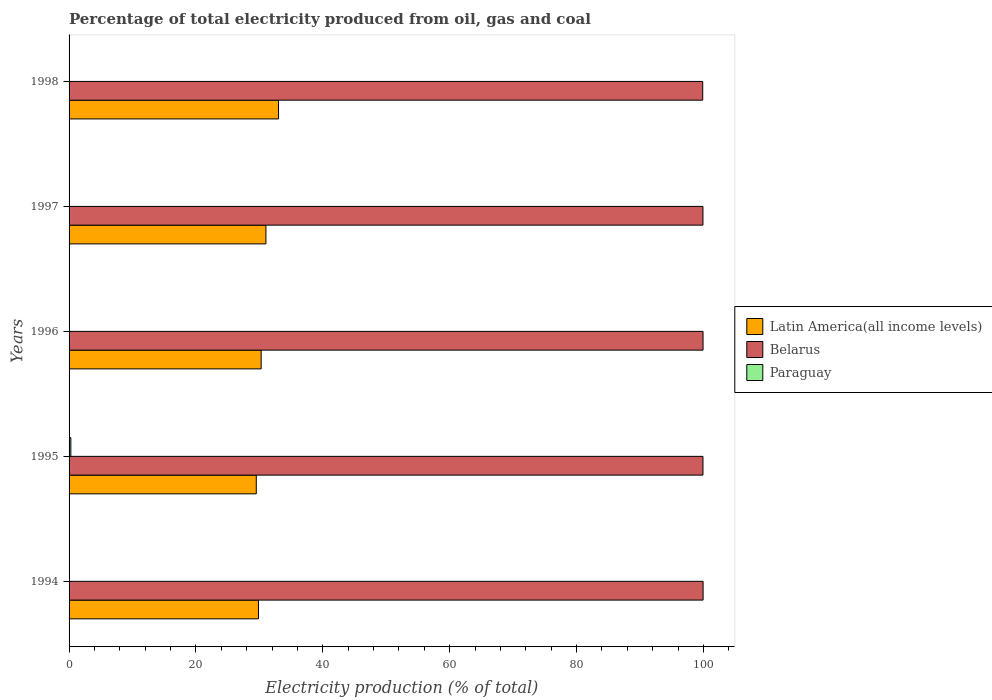How many different coloured bars are there?
Keep it short and to the point. 3. How many groups of bars are there?
Make the answer very short. 5. Are the number of bars per tick equal to the number of legend labels?
Make the answer very short. Yes. How many bars are there on the 1st tick from the top?
Provide a succinct answer. 3. How many bars are there on the 4th tick from the bottom?
Ensure brevity in your answer.  3. In how many cases, is the number of bars for a given year not equal to the number of legend labels?
Your answer should be very brief. 0. What is the electricity production in in Belarus in 1996?
Your answer should be very brief. 99.93. Across all years, what is the maximum electricity production in in Belarus?
Provide a succinct answer. 99.94. Across all years, what is the minimum electricity production in in Belarus?
Offer a very short reply. 99.88. In which year was the electricity production in in Paraguay minimum?
Your answer should be very brief. 1994. What is the total electricity production in in Latin America(all income levels) in the graph?
Your response must be concise. 153.7. What is the difference between the electricity production in in Latin America(all income levels) in 1996 and that in 1997?
Your answer should be compact. -0.75. What is the difference between the electricity production in in Latin America(all income levels) in 1994 and the electricity production in in Belarus in 1998?
Make the answer very short. -70.02. What is the average electricity production in in Paraguay per year?
Give a very brief answer. 0.08. In the year 1997, what is the difference between the electricity production in in Latin America(all income levels) and electricity production in in Belarus?
Give a very brief answer. -68.89. What is the ratio of the electricity production in in Paraguay in 1995 to that in 1998?
Offer a very short reply. 13.03. What is the difference between the highest and the second highest electricity production in in Paraguay?
Your response must be concise. 0.25. What is the difference between the highest and the lowest electricity production in in Latin America(all income levels)?
Your answer should be very brief. 3.51. In how many years, is the electricity production in in Belarus greater than the average electricity production in in Belarus taken over all years?
Make the answer very short. 4. Is the sum of the electricity production in in Latin America(all income levels) in 1996 and 1997 greater than the maximum electricity production in in Paraguay across all years?
Offer a terse response. Yes. What does the 3rd bar from the top in 1996 represents?
Provide a succinct answer. Latin America(all income levels). What does the 1st bar from the bottom in 1996 represents?
Provide a short and direct response. Latin America(all income levels). How many bars are there?
Your response must be concise. 15. Are all the bars in the graph horizontal?
Your response must be concise. Yes. What is the difference between two consecutive major ticks on the X-axis?
Offer a very short reply. 20. How many legend labels are there?
Make the answer very short. 3. What is the title of the graph?
Your answer should be compact. Percentage of total electricity produced from oil, gas and coal. What is the label or title of the X-axis?
Provide a succinct answer. Electricity production (% of total). What is the Electricity production (% of total) in Latin America(all income levels) in 1994?
Keep it short and to the point. 29.86. What is the Electricity production (% of total) of Belarus in 1994?
Your response must be concise. 99.94. What is the Electricity production (% of total) in Paraguay in 1994?
Ensure brevity in your answer.  0.02. What is the Electricity production (% of total) of Latin America(all income levels) in 1995?
Keep it short and to the point. 29.51. What is the Electricity production (% of total) in Belarus in 1995?
Offer a very short reply. 99.92. What is the Electricity production (% of total) of Paraguay in 1995?
Your answer should be very brief. 0.28. What is the Electricity production (% of total) of Latin America(all income levels) in 1996?
Provide a short and direct response. 30.28. What is the Electricity production (% of total) in Belarus in 1996?
Make the answer very short. 99.93. What is the Electricity production (% of total) in Paraguay in 1996?
Provide a short and direct response. 0.03. What is the Electricity production (% of total) in Latin America(all income levels) in 1997?
Your response must be concise. 31.03. What is the Electricity production (% of total) in Belarus in 1997?
Your answer should be compact. 99.92. What is the Electricity production (% of total) in Paraguay in 1997?
Keep it short and to the point. 0.02. What is the Electricity production (% of total) in Latin America(all income levels) in 1998?
Your answer should be compact. 33.02. What is the Electricity production (% of total) in Belarus in 1998?
Ensure brevity in your answer.  99.88. What is the Electricity production (% of total) of Paraguay in 1998?
Offer a very short reply. 0.02. Across all years, what is the maximum Electricity production (% of total) of Latin America(all income levels)?
Give a very brief answer. 33.02. Across all years, what is the maximum Electricity production (% of total) of Belarus?
Make the answer very short. 99.94. Across all years, what is the maximum Electricity production (% of total) in Paraguay?
Your answer should be very brief. 0.28. Across all years, what is the minimum Electricity production (% of total) in Latin America(all income levels)?
Make the answer very short. 29.51. Across all years, what is the minimum Electricity production (% of total) in Belarus?
Make the answer very short. 99.88. Across all years, what is the minimum Electricity production (% of total) in Paraguay?
Provide a short and direct response. 0.02. What is the total Electricity production (% of total) of Latin America(all income levels) in the graph?
Your response must be concise. 153.7. What is the total Electricity production (% of total) in Belarus in the graph?
Your answer should be very brief. 499.59. What is the total Electricity production (% of total) of Paraguay in the graph?
Give a very brief answer. 0.38. What is the difference between the Electricity production (% of total) of Latin America(all income levels) in 1994 and that in 1995?
Ensure brevity in your answer.  0.35. What is the difference between the Electricity production (% of total) of Belarus in 1994 and that in 1995?
Your answer should be compact. 0.02. What is the difference between the Electricity production (% of total) in Paraguay in 1994 and that in 1995?
Make the answer very short. -0.26. What is the difference between the Electricity production (% of total) of Latin America(all income levels) in 1994 and that in 1996?
Your response must be concise. -0.42. What is the difference between the Electricity production (% of total) in Belarus in 1994 and that in 1996?
Your answer should be very brief. 0.01. What is the difference between the Electricity production (% of total) in Paraguay in 1994 and that in 1996?
Provide a succinct answer. -0.01. What is the difference between the Electricity production (% of total) of Latin America(all income levels) in 1994 and that in 1997?
Keep it short and to the point. -1.18. What is the difference between the Electricity production (% of total) in Belarus in 1994 and that in 1997?
Your answer should be very brief. 0.02. What is the difference between the Electricity production (% of total) in Paraguay in 1994 and that in 1997?
Offer a very short reply. -0. What is the difference between the Electricity production (% of total) of Latin America(all income levels) in 1994 and that in 1998?
Provide a short and direct response. -3.16. What is the difference between the Electricity production (% of total) of Belarus in 1994 and that in 1998?
Keep it short and to the point. 0.06. What is the difference between the Electricity production (% of total) of Paraguay in 1994 and that in 1998?
Your response must be concise. -0. What is the difference between the Electricity production (% of total) of Latin America(all income levels) in 1995 and that in 1996?
Give a very brief answer. -0.77. What is the difference between the Electricity production (% of total) of Belarus in 1995 and that in 1996?
Ensure brevity in your answer.  -0.01. What is the difference between the Electricity production (% of total) of Paraguay in 1995 and that in 1996?
Ensure brevity in your answer.  0.25. What is the difference between the Electricity production (% of total) of Latin America(all income levels) in 1995 and that in 1997?
Give a very brief answer. -1.52. What is the difference between the Electricity production (% of total) in Belarus in 1995 and that in 1997?
Your answer should be very brief. 0. What is the difference between the Electricity production (% of total) in Paraguay in 1995 and that in 1997?
Your answer should be compact. 0.26. What is the difference between the Electricity production (% of total) in Latin America(all income levels) in 1995 and that in 1998?
Provide a short and direct response. -3.51. What is the difference between the Electricity production (% of total) in Belarus in 1995 and that in 1998?
Your answer should be very brief. 0.04. What is the difference between the Electricity production (% of total) in Paraguay in 1995 and that in 1998?
Offer a terse response. 0.26. What is the difference between the Electricity production (% of total) of Latin America(all income levels) in 1996 and that in 1997?
Your answer should be compact. -0.75. What is the difference between the Electricity production (% of total) in Belarus in 1996 and that in 1997?
Provide a short and direct response. 0.01. What is the difference between the Electricity production (% of total) in Paraguay in 1996 and that in 1997?
Make the answer very short. 0.01. What is the difference between the Electricity production (% of total) in Latin America(all income levels) in 1996 and that in 1998?
Make the answer very short. -2.74. What is the difference between the Electricity production (% of total) of Belarus in 1996 and that in 1998?
Offer a terse response. 0.05. What is the difference between the Electricity production (% of total) of Paraguay in 1996 and that in 1998?
Give a very brief answer. 0.01. What is the difference between the Electricity production (% of total) of Latin America(all income levels) in 1997 and that in 1998?
Offer a terse response. -1.98. What is the difference between the Electricity production (% of total) of Belarus in 1997 and that in 1998?
Your answer should be very brief. 0.04. What is the difference between the Electricity production (% of total) of Paraguay in 1997 and that in 1998?
Your answer should be compact. 0. What is the difference between the Electricity production (% of total) in Latin America(all income levels) in 1994 and the Electricity production (% of total) in Belarus in 1995?
Provide a succinct answer. -70.06. What is the difference between the Electricity production (% of total) in Latin America(all income levels) in 1994 and the Electricity production (% of total) in Paraguay in 1995?
Offer a very short reply. 29.58. What is the difference between the Electricity production (% of total) in Belarus in 1994 and the Electricity production (% of total) in Paraguay in 1995?
Offer a very short reply. 99.66. What is the difference between the Electricity production (% of total) in Latin America(all income levels) in 1994 and the Electricity production (% of total) in Belarus in 1996?
Ensure brevity in your answer.  -70.08. What is the difference between the Electricity production (% of total) of Latin America(all income levels) in 1994 and the Electricity production (% of total) of Paraguay in 1996?
Make the answer very short. 29.82. What is the difference between the Electricity production (% of total) in Belarus in 1994 and the Electricity production (% of total) in Paraguay in 1996?
Your answer should be very brief. 99.91. What is the difference between the Electricity production (% of total) of Latin America(all income levels) in 1994 and the Electricity production (% of total) of Belarus in 1997?
Offer a terse response. -70.06. What is the difference between the Electricity production (% of total) in Latin America(all income levels) in 1994 and the Electricity production (% of total) in Paraguay in 1997?
Provide a succinct answer. 29.84. What is the difference between the Electricity production (% of total) of Belarus in 1994 and the Electricity production (% of total) of Paraguay in 1997?
Your response must be concise. 99.92. What is the difference between the Electricity production (% of total) in Latin America(all income levels) in 1994 and the Electricity production (% of total) in Belarus in 1998?
Ensure brevity in your answer.  -70.02. What is the difference between the Electricity production (% of total) in Latin America(all income levels) in 1994 and the Electricity production (% of total) in Paraguay in 1998?
Provide a succinct answer. 29.84. What is the difference between the Electricity production (% of total) of Belarus in 1994 and the Electricity production (% of total) of Paraguay in 1998?
Make the answer very short. 99.92. What is the difference between the Electricity production (% of total) in Latin America(all income levels) in 1995 and the Electricity production (% of total) in Belarus in 1996?
Offer a terse response. -70.42. What is the difference between the Electricity production (% of total) in Latin America(all income levels) in 1995 and the Electricity production (% of total) in Paraguay in 1996?
Provide a short and direct response. 29.48. What is the difference between the Electricity production (% of total) in Belarus in 1995 and the Electricity production (% of total) in Paraguay in 1996?
Give a very brief answer. 99.89. What is the difference between the Electricity production (% of total) in Latin America(all income levels) in 1995 and the Electricity production (% of total) in Belarus in 1997?
Ensure brevity in your answer.  -70.41. What is the difference between the Electricity production (% of total) in Latin America(all income levels) in 1995 and the Electricity production (% of total) in Paraguay in 1997?
Offer a very short reply. 29.49. What is the difference between the Electricity production (% of total) of Belarus in 1995 and the Electricity production (% of total) of Paraguay in 1997?
Make the answer very short. 99.9. What is the difference between the Electricity production (% of total) of Latin America(all income levels) in 1995 and the Electricity production (% of total) of Belarus in 1998?
Your response must be concise. -70.37. What is the difference between the Electricity production (% of total) of Latin America(all income levels) in 1995 and the Electricity production (% of total) of Paraguay in 1998?
Your answer should be compact. 29.49. What is the difference between the Electricity production (% of total) in Belarus in 1995 and the Electricity production (% of total) in Paraguay in 1998?
Your answer should be compact. 99.9. What is the difference between the Electricity production (% of total) in Latin America(all income levels) in 1996 and the Electricity production (% of total) in Belarus in 1997?
Keep it short and to the point. -69.64. What is the difference between the Electricity production (% of total) of Latin America(all income levels) in 1996 and the Electricity production (% of total) of Paraguay in 1997?
Provide a succinct answer. 30.26. What is the difference between the Electricity production (% of total) in Belarus in 1996 and the Electricity production (% of total) in Paraguay in 1997?
Your response must be concise. 99.91. What is the difference between the Electricity production (% of total) in Latin America(all income levels) in 1996 and the Electricity production (% of total) in Belarus in 1998?
Make the answer very short. -69.6. What is the difference between the Electricity production (% of total) in Latin America(all income levels) in 1996 and the Electricity production (% of total) in Paraguay in 1998?
Your answer should be compact. 30.26. What is the difference between the Electricity production (% of total) in Belarus in 1996 and the Electricity production (% of total) in Paraguay in 1998?
Provide a succinct answer. 99.91. What is the difference between the Electricity production (% of total) of Latin America(all income levels) in 1997 and the Electricity production (% of total) of Belarus in 1998?
Give a very brief answer. -68.85. What is the difference between the Electricity production (% of total) of Latin America(all income levels) in 1997 and the Electricity production (% of total) of Paraguay in 1998?
Provide a succinct answer. 31.01. What is the difference between the Electricity production (% of total) in Belarus in 1997 and the Electricity production (% of total) in Paraguay in 1998?
Make the answer very short. 99.9. What is the average Electricity production (% of total) in Latin America(all income levels) per year?
Provide a short and direct response. 30.74. What is the average Electricity production (% of total) in Belarus per year?
Offer a terse response. 99.92. What is the average Electricity production (% of total) of Paraguay per year?
Your answer should be compact. 0.08. In the year 1994, what is the difference between the Electricity production (% of total) of Latin America(all income levels) and Electricity production (% of total) of Belarus?
Provide a succinct answer. -70.08. In the year 1994, what is the difference between the Electricity production (% of total) in Latin America(all income levels) and Electricity production (% of total) in Paraguay?
Ensure brevity in your answer.  29.84. In the year 1994, what is the difference between the Electricity production (% of total) in Belarus and Electricity production (% of total) in Paraguay?
Make the answer very short. 99.92. In the year 1995, what is the difference between the Electricity production (% of total) in Latin America(all income levels) and Electricity production (% of total) in Belarus?
Give a very brief answer. -70.41. In the year 1995, what is the difference between the Electricity production (% of total) of Latin America(all income levels) and Electricity production (% of total) of Paraguay?
Give a very brief answer. 29.23. In the year 1995, what is the difference between the Electricity production (% of total) of Belarus and Electricity production (% of total) of Paraguay?
Your answer should be compact. 99.64. In the year 1996, what is the difference between the Electricity production (% of total) of Latin America(all income levels) and Electricity production (% of total) of Belarus?
Keep it short and to the point. -69.65. In the year 1996, what is the difference between the Electricity production (% of total) in Latin America(all income levels) and Electricity production (% of total) in Paraguay?
Keep it short and to the point. 30.25. In the year 1996, what is the difference between the Electricity production (% of total) in Belarus and Electricity production (% of total) in Paraguay?
Provide a short and direct response. 99.9. In the year 1997, what is the difference between the Electricity production (% of total) of Latin America(all income levels) and Electricity production (% of total) of Belarus?
Your answer should be very brief. -68.89. In the year 1997, what is the difference between the Electricity production (% of total) in Latin America(all income levels) and Electricity production (% of total) in Paraguay?
Your response must be concise. 31.01. In the year 1997, what is the difference between the Electricity production (% of total) of Belarus and Electricity production (% of total) of Paraguay?
Provide a short and direct response. 99.9. In the year 1998, what is the difference between the Electricity production (% of total) in Latin America(all income levels) and Electricity production (% of total) in Belarus?
Keep it short and to the point. -66.86. In the year 1998, what is the difference between the Electricity production (% of total) in Latin America(all income levels) and Electricity production (% of total) in Paraguay?
Provide a succinct answer. 32.99. In the year 1998, what is the difference between the Electricity production (% of total) in Belarus and Electricity production (% of total) in Paraguay?
Provide a short and direct response. 99.86. What is the ratio of the Electricity production (% of total) of Latin America(all income levels) in 1994 to that in 1995?
Your answer should be very brief. 1.01. What is the ratio of the Electricity production (% of total) in Belarus in 1994 to that in 1995?
Offer a very short reply. 1. What is the ratio of the Electricity production (% of total) of Paraguay in 1994 to that in 1995?
Your response must be concise. 0.07. What is the ratio of the Electricity production (% of total) of Paraguay in 1994 to that in 1996?
Your answer should be compact. 0.57. What is the ratio of the Electricity production (% of total) of Latin America(all income levels) in 1994 to that in 1997?
Offer a terse response. 0.96. What is the ratio of the Electricity production (% of total) in Belarus in 1994 to that in 1997?
Make the answer very short. 1. What is the ratio of the Electricity production (% of total) in Paraguay in 1994 to that in 1997?
Provide a succinct answer. 0.89. What is the ratio of the Electricity production (% of total) in Latin America(all income levels) in 1994 to that in 1998?
Make the answer very short. 0.9. What is the ratio of the Electricity production (% of total) of Belarus in 1994 to that in 1998?
Offer a terse response. 1. What is the ratio of the Electricity production (% of total) of Paraguay in 1994 to that in 1998?
Offer a terse response. 0.89. What is the ratio of the Electricity production (% of total) in Latin America(all income levels) in 1995 to that in 1996?
Your answer should be very brief. 0.97. What is the ratio of the Electricity production (% of total) in Paraguay in 1995 to that in 1996?
Provide a short and direct response. 8.42. What is the ratio of the Electricity production (% of total) in Latin America(all income levels) in 1995 to that in 1997?
Your response must be concise. 0.95. What is the ratio of the Electricity production (% of total) of Belarus in 1995 to that in 1997?
Your response must be concise. 1. What is the ratio of the Electricity production (% of total) in Paraguay in 1995 to that in 1997?
Ensure brevity in your answer.  13.03. What is the ratio of the Electricity production (% of total) in Latin America(all income levels) in 1995 to that in 1998?
Offer a terse response. 0.89. What is the ratio of the Electricity production (% of total) of Belarus in 1995 to that in 1998?
Provide a succinct answer. 1. What is the ratio of the Electricity production (% of total) in Paraguay in 1995 to that in 1998?
Keep it short and to the point. 13.03. What is the ratio of the Electricity production (% of total) of Latin America(all income levels) in 1996 to that in 1997?
Give a very brief answer. 0.98. What is the ratio of the Electricity production (% of total) in Paraguay in 1996 to that in 1997?
Give a very brief answer. 1.55. What is the ratio of the Electricity production (% of total) in Latin America(all income levels) in 1996 to that in 1998?
Give a very brief answer. 0.92. What is the ratio of the Electricity production (% of total) of Paraguay in 1996 to that in 1998?
Keep it short and to the point. 1.55. What is the ratio of the Electricity production (% of total) in Latin America(all income levels) in 1997 to that in 1998?
Make the answer very short. 0.94. What is the difference between the highest and the second highest Electricity production (% of total) of Latin America(all income levels)?
Make the answer very short. 1.98. What is the difference between the highest and the second highest Electricity production (% of total) of Belarus?
Your response must be concise. 0.01. What is the difference between the highest and the second highest Electricity production (% of total) of Paraguay?
Make the answer very short. 0.25. What is the difference between the highest and the lowest Electricity production (% of total) in Latin America(all income levels)?
Provide a short and direct response. 3.51. What is the difference between the highest and the lowest Electricity production (% of total) of Belarus?
Ensure brevity in your answer.  0.06. What is the difference between the highest and the lowest Electricity production (% of total) in Paraguay?
Keep it short and to the point. 0.26. 